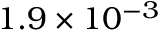Convert formula to latex. <formula><loc_0><loc_0><loc_500><loc_500>1 . 9 \times 1 0 ^ { - 3 }</formula> 